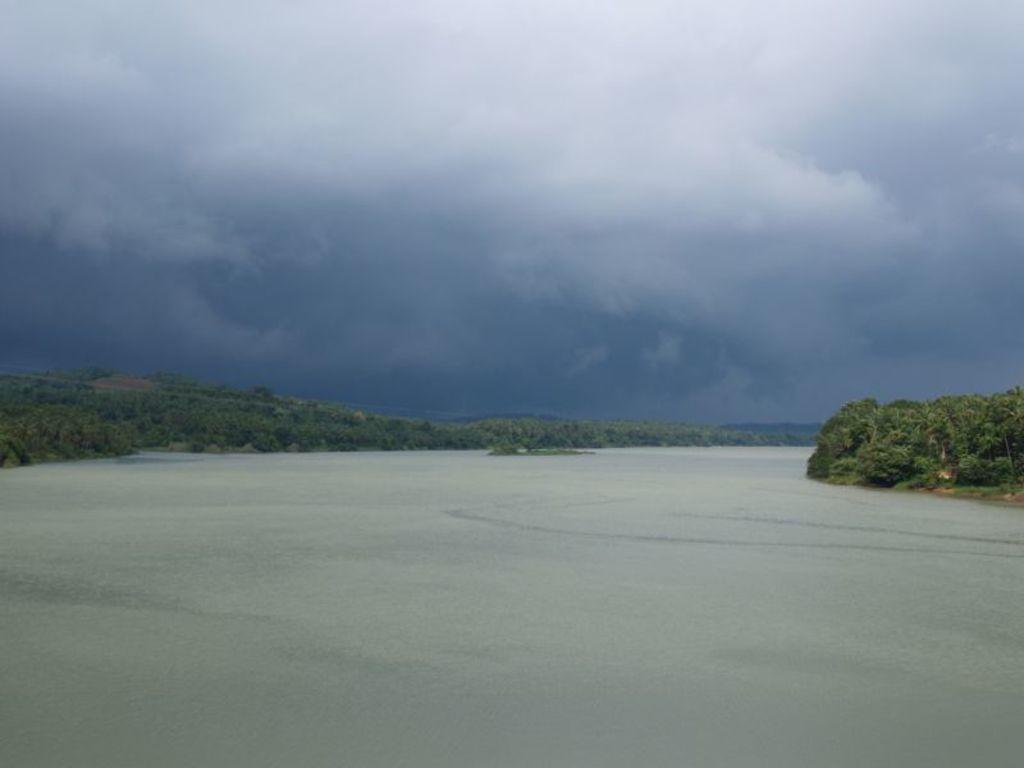In one or two sentences, can you explain what this image depicts? In this image we can see some trees and water, in the background, we can see the sky with clouds. 